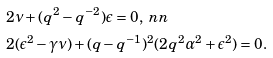Convert formula to latex. <formula><loc_0><loc_0><loc_500><loc_500>& 2 \nu + ( q ^ { 2 } - q ^ { - 2 } ) \epsilon = 0 , \ n n \\ & 2 ( \epsilon ^ { 2 } - \gamma \nu ) + ( q - q ^ { - 1 } ) ^ { 2 } ( 2 q ^ { 2 } \alpha ^ { 2 } + \epsilon ^ { 2 } ) = 0 .</formula> 